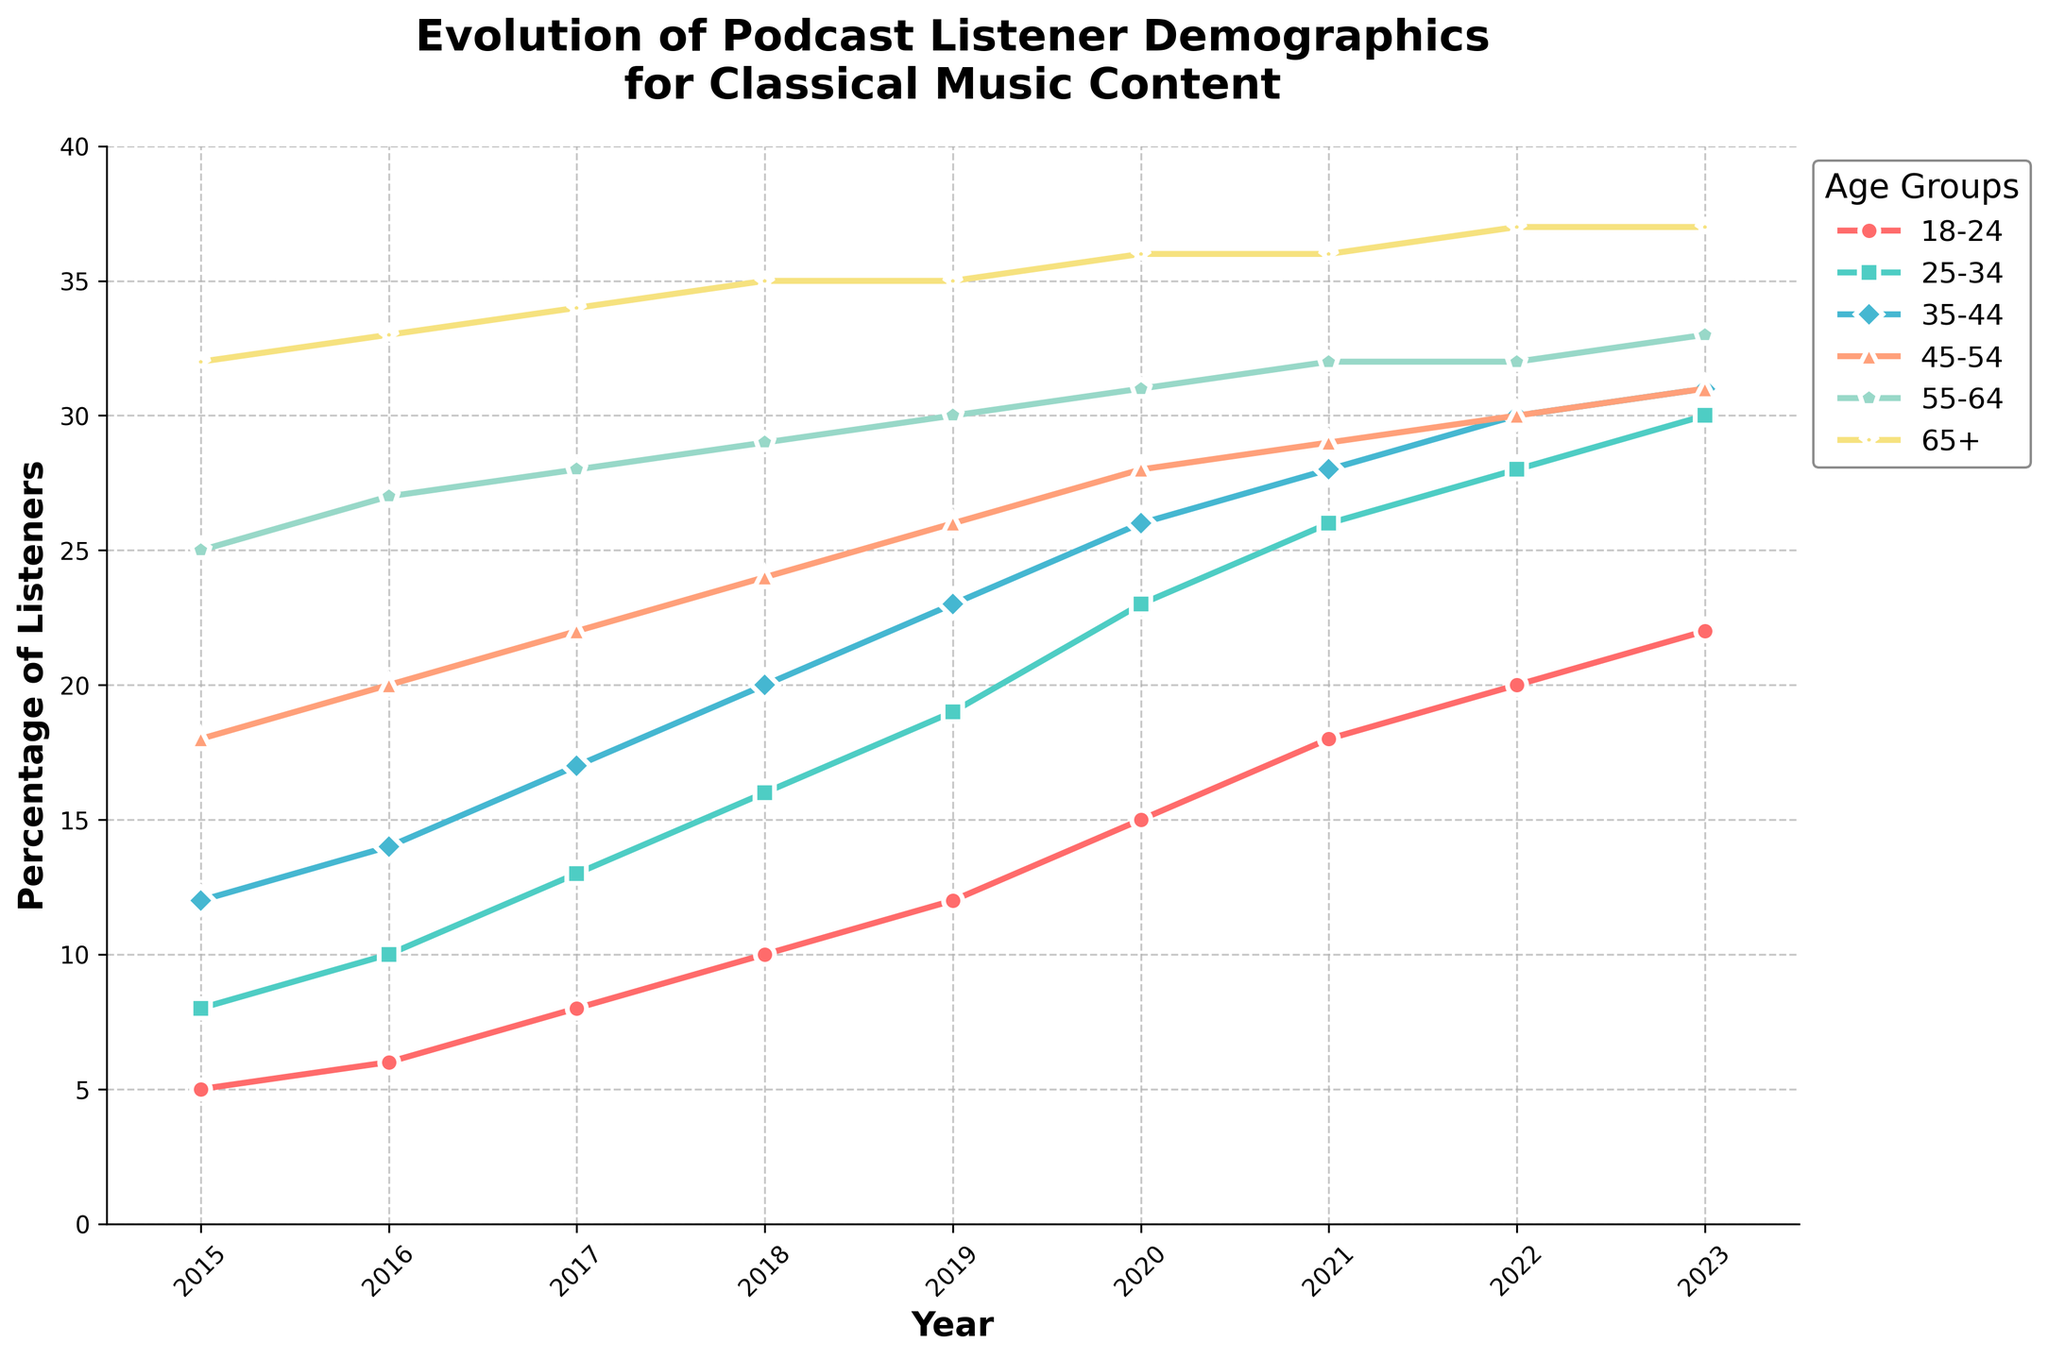What is the total percentage of listeners in the 18-24 age group in 2023? Look for the data point corresponding to the 18-24 age group in 2023, which is 22%. This is already a sum of the number of listeners in that age group for that year.
Answer: 22% Between which years did the 25-34 age group see the largest increase in percentage? Compare the increments year by year for the 25-34 age group. The largest increases are between 2019 and 2020 (increment of 4).
Answer: 2019 and 2020 Which age group had the smallest change in percentage from 2015 to 2023? Compare the difference from 2015 to 2023 for each age group. Percentages in 2015 and 2023 for each age group are: 18-24 (5 to 22), 25-34 (8 to 30), 35-44 (12 to 31), 45-54 (18 to 31), 55-64 (25 to 33), 65+ (32 to 37). The smallest change is seen in the 65+ group (difference of 5).
Answer: 65+ What was the percentage of listeners for the 55-64 age group in 2020? Locate the data point for the 55-64 age group in the year 2020, which is 31%.
Answer: 31% How many years did it take for the 18-24 age group to more than triple in percentage? Compare the percentage of the 18-24 age group across the years. In 2015 it was 5%, and more than triple (15%) by 2020. Hence, it took 5 years.
Answer: 5 years Which two age groups had nearly identical percentages in 2022? Check each age group’s percentage for 2022. The 45-54 (30%) and 55-64 (32%) groups are close, but 35-44 and 45-54 groups both have 30%.
Answer: 35-44 and 45-54 In what year did the 35-44 age group surpass the 25-34 age group in percentage? Compare the data for the 35-44 and 25-34 age groups across the years. The 35-44 age group has always been higher than the 25-34 group.
Answer: It never did Which age group consistently had the highest percentage of listeners from 2015 to 2023? Check the percentage for each age group each year. The 65+ age group always had the highest percentage.
Answer: 65+ By how much did the percentage of listeners increase in the 45-54 age group from 2018 to 2021? Subtract the percentage for 45-54 in 2018 (24%) from that in 2021 (29%). The increase is 29% - 24% = 5%.
Answer: 5% What was the average percentage of listeners for the 25-34 age group over the entire period? Sum the percentages for 25-34 for all years: (8 + 10 + 13 + 16 + 19 + 23 + 26 + 28 + 30). The total is 173. There are 9 years, so the average is 173 / 9 = 19.2%.
Answer: 19.2% 